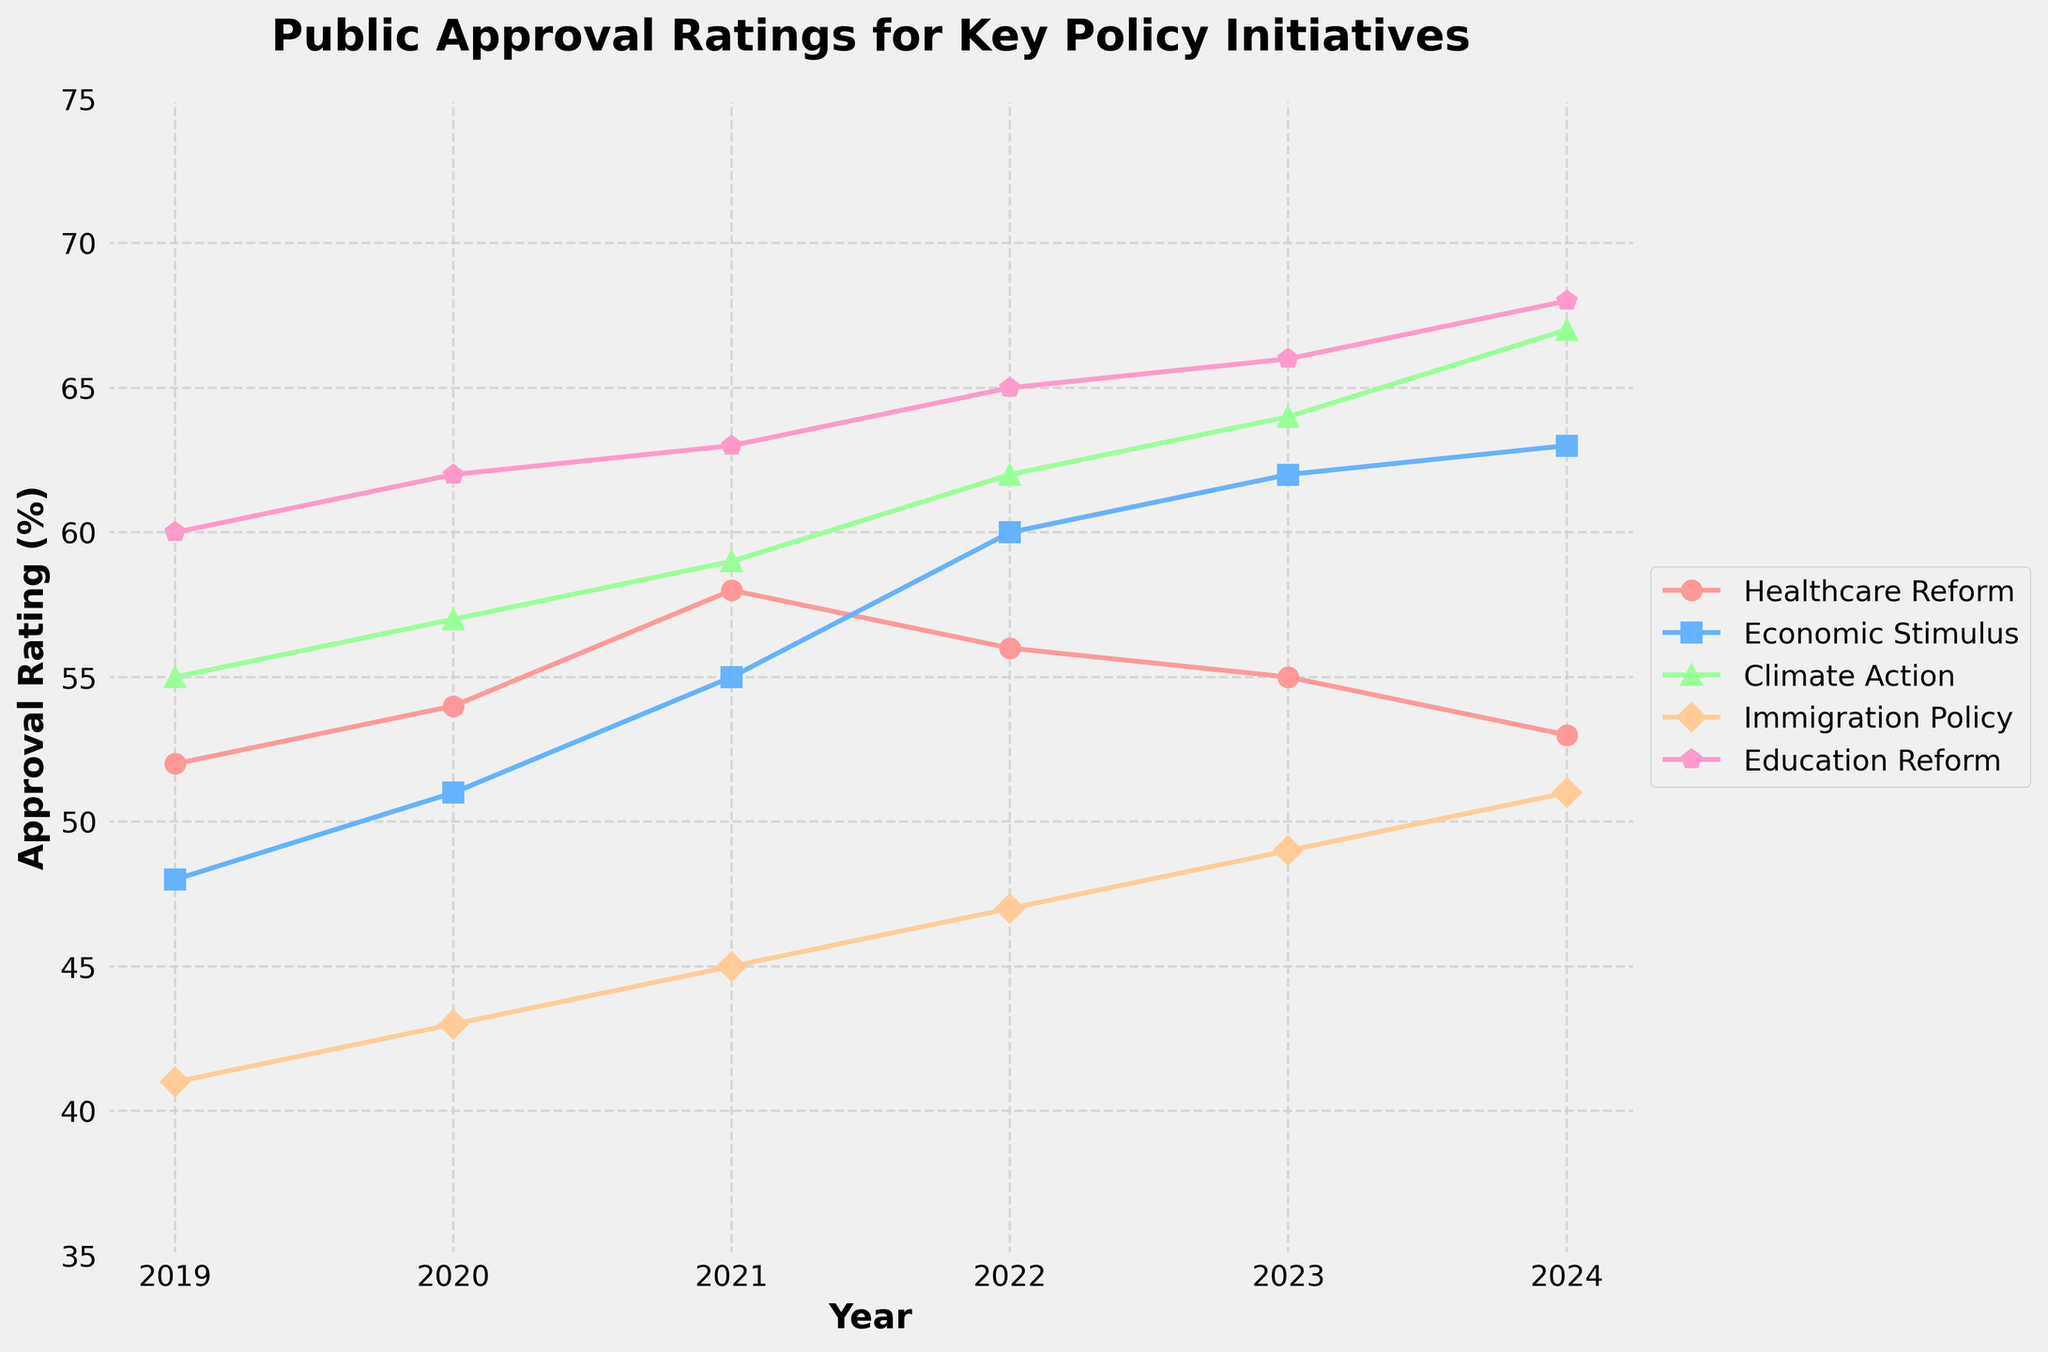Which policy initiative had the highest public approval rating in 2024? The figure shows the public approval ratings for various policy initiatives over the years. In 2024, Education Reform has the highest approval rating with a value of 68.
Answer: Education Reform How did the approval rating for Healthcare Reform change from 2021 to 2023? Referencing the figure, the approval rating for Healthcare Reform was 58 in 2021 and dropped to 55 in 2023. The change can be calculated as 55 - 58 = -3, indicating a decrease.
Answer: Decreased by 3 Which year saw the largest increase in approval rating for Economic Stimulus? By observing the figure, the approval rating for Economic Stimulus increased from 51 in 2020 to 55 in 2021, which is a 4-point increase. This period shows the largest increase compared to other years.
Answer: 2021 What is the average approval rating for Climate Action from 2019 to 2024? First, sum up the approval ratings for Climate Action from 2019 (55), 2020 (57), 2021 (59), 2022 (62), 2023 (64), and 2024 (67). The total sum is 364. Then, divide by the number of years (6), resulting in 364 / 6 = 60.67.
Answer: 60.67 Which policy had the greatest improvement in approval ratings from 2019 to 2024? Compare the approval ratings from 2019 to 2024 for each policy. Education Reform increased from 60 to 68, Immigration Policy from 41 to 51, Economic Stimulus from 48 to 63, Healthcare Reform from 52 to 53, and Climate Action from 55 to 67. The greatest improvement is Climate Action with an increase of 12 points.
Answer: Climate Action In which years was the approval rating for Immigration Policy the lowest? By inspecting the figure, Immigration Policy had its lowest approval rating in 2019 with a value of 41.
Answer: 2019 What is the combined approval rating for Economic Stimulus and Education Reform in 2023? According to the figure, the approval rating for Economic Stimulus in 2023 is 62 and for Education Reform is 66. The combined approval rating is 62 + 66 = 128.
Answer: 128 How many years did the approval rating for Healthcare Reform remain above 55? The figure shows that Healthcare Reform's ratings were above 55 in the years 2021 (58), 2022 (56), 2023 (55).
Answer: 3 years Which policy initiative had the most stable approval rating (least variability) throughout the years? By comparing the fluctuations in approval ratings for all policies, Education Reform appears the most stable, consistently increasing from 60 in 2019 to 68 in 2024. Its changes are incremental and show the least variability.
Answer: Education Reform 